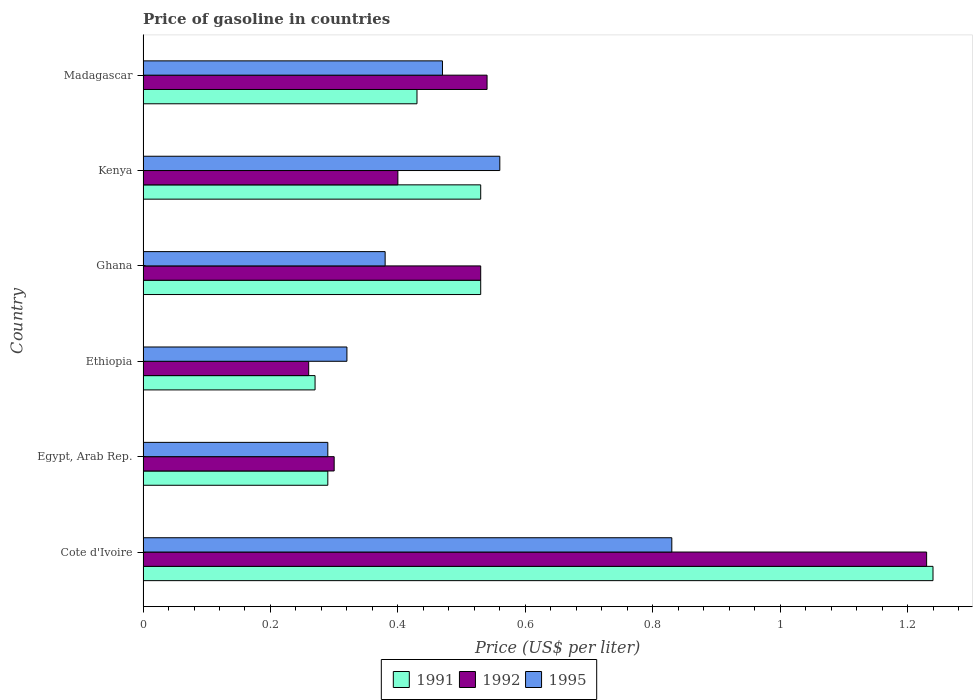Are the number of bars on each tick of the Y-axis equal?
Your response must be concise. Yes. What is the label of the 2nd group of bars from the top?
Your response must be concise. Kenya. In how many cases, is the number of bars for a given country not equal to the number of legend labels?
Ensure brevity in your answer.  0. What is the price of gasoline in 1995 in Madagascar?
Your answer should be very brief. 0.47. Across all countries, what is the maximum price of gasoline in 1991?
Ensure brevity in your answer.  1.24. Across all countries, what is the minimum price of gasoline in 1991?
Your response must be concise. 0.27. In which country was the price of gasoline in 1991 maximum?
Give a very brief answer. Cote d'Ivoire. In which country was the price of gasoline in 1995 minimum?
Ensure brevity in your answer.  Egypt, Arab Rep. What is the total price of gasoline in 1992 in the graph?
Your answer should be compact. 3.26. What is the difference between the price of gasoline in 1995 in Ghana and that in Madagascar?
Make the answer very short. -0.09. What is the difference between the price of gasoline in 1992 in Kenya and the price of gasoline in 1995 in Egypt, Arab Rep.?
Your answer should be very brief. 0.11. What is the average price of gasoline in 1991 per country?
Ensure brevity in your answer.  0.55. What is the difference between the price of gasoline in 1991 and price of gasoline in 1992 in Ghana?
Offer a very short reply. 0. What is the ratio of the price of gasoline in 1991 in Ethiopia to that in Kenya?
Your answer should be very brief. 0.51. Is the difference between the price of gasoline in 1991 in Cote d'Ivoire and Madagascar greater than the difference between the price of gasoline in 1992 in Cote d'Ivoire and Madagascar?
Offer a very short reply. Yes. What is the difference between the highest and the second highest price of gasoline in 1992?
Offer a very short reply. 0.69. What is the difference between the highest and the lowest price of gasoline in 1995?
Your response must be concise. 0.54. Is the sum of the price of gasoline in 1992 in Egypt, Arab Rep. and Madagascar greater than the maximum price of gasoline in 1991 across all countries?
Ensure brevity in your answer.  No. What does the 3rd bar from the top in Madagascar represents?
Make the answer very short. 1991. Is it the case that in every country, the sum of the price of gasoline in 1991 and price of gasoline in 1992 is greater than the price of gasoline in 1995?
Make the answer very short. Yes. How many bars are there?
Your answer should be very brief. 18. How many countries are there in the graph?
Ensure brevity in your answer.  6. Does the graph contain any zero values?
Give a very brief answer. No. Does the graph contain grids?
Keep it short and to the point. No. How are the legend labels stacked?
Offer a very short reply. Horizontal. What is the title of the graph?
Your answer should be very brief. Price of gasoline in countries. Does "1988" appear as one of the legend labels in the graph?
Your answer should be very brief. No. What is the label or title of the X-axis?
Give a very brief answer. Price (US$ per liter). What is the label or title of the Y-axis?
Offer a very short reply. Country. What is the Price (US$ per liter) of 1991 in Cote d'Ivoire?
Your answer should be very brief. 1.24. What is the Price (US$ per liter) of 1992 in Cote d'Ivoire?
Provide a short and direct response. 1.23. What is the Price (US$ per liter) in 1995 in Cote d'Ivoire?
Ensure brevity in your answer.  0.83. What is the Price (US$ per liter) of 1991 in Egypt, Arab Rep.?
Offer a terse response. 0.29. What is the Price (US$ per liter) in 1992 in Egypt, Arab Rep.?
Provide a succinct answer. 0.3. What is the Price (US$ per liter) of 1995 in Egypt, Arab Rep.?
Your answer should be compact. 0.29. What is the Price (US$ per liter) in 1991 in Ethiopia?
Provide a succinct answer. 0.27. What is the Price (US$ per liter) in 1992 in Ethiopia?
Provide a short and direct response. 0.26. What is the Price (US$ per liter) of 1995 in Ethiopia?
Your answer should be compact. 0.32. What is the Price (US$ per liter) in 1991 in Ghana?
Give a very brief answer. 0.53. What is the Price (US$ per liter) of 1992 in Ghana?
Your response must be concise. 0.53. What is the Price (US$ per liter) in 1995 in Ghana?
Provide a short and direct response. 0.38. What is the Price (US$ per liter) in 1991 in Kenya?
Offer a terse response. 0.53. What is the Price (US$ per liter) in 1995 in Kenya?
Your response must be concise. 0.56. What is the Price (US$ per liter) in 1991 in Madagascar?
Your response must be concise. 0.43. What is the Price (US$ per liter) in 1992 in Madagascar?
Ensure brevity in your answer.  0.54. What is the Price (US$ per liter) of 1995 in Madagascar?
Your answer should be compact. 0.47. Across all countries, what is the maximum Price (US$ per liter) of 1991?
Offer a very short reply. 1.24. Across all countries, what is the maximum Price (US$ per liter) of 1992?
Give a very brief answer. 1.23. Across all countries, what is the maximum Price (US$ per liter) of 1995?
Offer a very short reply. 0.83. Across all countries, what is the minimum Price (US$ per liter) in 1991?
Give a very brief answer. 0.27. Across all countries, what is the minimum Price (US$ per liter) of 1992?
Provide a short and direct response. 0.26. Across all countries, what is the minimum Price (US$ per liter) of 1995?
Offer a terse response. 0.29. What is the total Price (US$ per liter) of 1991 in the graph?
Provide a succinct answer. 3.29. What is the total Price (US$ per liter) of 1992 in the graph?
Your answer should be compact. 3.26. What is the total Price (US$ per liter) of 1995 in the graph?
Keep it short and to the point. 2.85. What is the difference between the Price (US$ per liter) of 1992 in Cote d'Ivoire and that in Egypt, Arab Rep.?
Keep it short and to the point. 0.93. What is the difference between the Price (US$ per liter) in 1995 in Cote d'Ivoire and that in Egypt, Arab Rep.?
Make the answer very short. 0.54. What is the difference between the Price (US$ per liter) in 1992 in Cote d'Ivoire and that in Ethiopia?
Provide a succinct answer. 0.97. What is the difference between the Price (US$ per liter) of 1995 in Cote d'Ivoire and that in Ethiopia?
Provide a succinct answer. 0.51. What is the difference between the Price (US$ per liter) in 1991 in Cote d'Ivoire and that in Ghana?
Your answer should be very brief. 0.71. What is the difference between the Price (US$ per liter) of 1992 in Cote d'Ivoire and that in Ghana?
Provide a short and direct response. 0.7. What is the difference between the Price (US$ per liter) of 1995 in Cote d'Ivoire and that in Ghana?
Your answer should be compact. 0.45. What is the difference between the Price (US$ per liter) in 1991 in Cote d'Ivoire and that in Kenya?
Offer a very short reply. 0.71. What is the difference between the Price (US$ per liter) in 1992 in Cote d'Ivoire and that in Kenya?
Ensure brevity in your answer.  0.83. What is the difference between the Price (US$ per liter) in 1995 in Cote d'Ivoire and that in Kenya?
Make the answer very short. 0.27. What is the difference between the Price (US$ per liter) of 1991 in Cote d'Ivoire and that in Madagascar?
Your answer should be compact. 0.81. What is the difference between the Price (US$ per liter) of 1992 in Cote d'Ivoire and that in Madagascar?
Your answer should be very brief. 0.69. What is the difference between the Price (US$ per liter) in 1995 in Cote d'Ivoire and that in Madagascar?
Offer a very short reply. 0.36. What is the difference between the Price (US$ per liter) of 1995 in Egypt, Arab Rep. and that in Ethiopia?
Your response must be concise. -0.03. What is the difference between the Price (US$ per liter) in 1991 in Egypt, Arab Rep. and that in Ghana?
Your answer should be very brief. -0.24. What is the difference between the Price (US$ per liter) in 1992 in Egypt, Arab Rep. and that in Ghana?
Your response must be concise. -0.23. What is the difference between the Price (US$ per liter) in 1995 in Egypt, Arab Rep. and that in Ghana?
Keep it short and to the point. -0.09. What is the difference between the Price (US$ per liter) of 1991 in Egypt, Arab Rep. and that in Kenya?
Provide a short and direct response. -0.24. What is the difference between the Price (US$ per liter) in 1992 in Egypt, Arab Rep. and that in Kenya?
Provide a succinct answer. -0.1. What is the difference between the Price (US$ per liter) in 1995 in Egypt, Arab Rep. and that in Kenya?
Make the answer very short. -0.27. What is the difference between the Price (US$ per liter) of 1991 in Egypt, Arab Rep. and that in Madagascar?
Make the answer very short. -0.14. What is the difference between the Price (US$ per liter) in 1992 in Egypt, Arab Rep. and that in Madagascar?
Provide a short and direct response. -0.24. What is the difference between the Price (US$ per liter) of 1995 in Egypt, Arab Rep. and that in Madagascar?
Offer a terse response. -0.18. What is the difference between the Price (US$ per liter) in 1991 in Ethiopia and that in Ghana?
Offer a very short reply. -0.26. What is the difference between the Price (US$ per liter) of 1992 in Ethiopia and that in Ghana?
Offer a very short reply. -0.27. What is the difference between the Price (US$ per liter) in 1995 in Ethiopia and that in Ghana?
Make the answer very short. -0.06. What is the difference between the Price (US$ per liter) of 1991 in Ethiopia and that in Kenya?
Provide a succinct answer. -0.26. What is the difference between the Price (US$ per liter) in 1992 in Ethiopia and that in Kenya?
Keep it short and to the point. -0.14. What is the difference between the Price (US$ per liter) of 1995 in Ethiopia and that in Kenya?
Offer a very short reply. -0.24. What is the difference between the Price (US$ per liter) in 1991 in Ethiopia and that in Madagascar?
Your answer should be compact. -0.16. What is the difference between the Price (US$ per liter) in 1992 in Ethiopia and that in Madagascar?
Your answer should be very brief. -0.28. What is the difference between the Price (US$ per liter) in 1995 in Ethiopia and that in Madagascar?
Your answer should be compact. -0.15. What is the difference between the Price (US$ per liter) in 1991 in Ghana and that in Kenya?
Give a very brief answer. 0. What is the difference between the Price (US$ per liter) of 1992 in Ghana and that in Kenya?
Offer a terse response. 0.13. What is the difference between the Price (US$ per liter) in 1995 in Ghana and that in Kenya?
Your response must be concise. -0.18. What is the difference between the Price (US$ per liter) in 1992 in Ghana and that in Madagascar?
Keep it short and to the point. -0.01. What is the difference between the Price (US$ per liter) in 1995 in Ghana and that in Madagascar?
Give a very brief answer. -0.09. What is the difference between the Price (US$ per liter) in 1991 in Kenya and that in Madagascar?
Your response must be concise. 0.1. What is the difference between the Price (US$ per liter) in 1992 in Kenya and that in Madagascar?
Give a very brief answer. -0.14. What is the difference between the Price (US$ per liter) of 1995 in Kenya and that in Madagascar?
Provide a short and direct response. 0.09. What is the difference between the Price (US$ per liter) in 1992 in Cote d'Ivoire and the Price (US$ per liter) in 1995 in Egypt, Arab Rep.?
Keep it short and to the point. 0.94. What is the difference between the Price (US$ per liter) of 1991 in Cote d'Ivoire and the Price (US$ per liter) of 1992 in Ethiopia?
Offer a very short reply. 0.98. What is the difference between the Price (US$ per liter) in 1991 in Cote d'Ivoire and the Price (US$ per liter) in 1995 in Ethiopia?
Keep it short and to the point. 0.92. What is the difference between the Price (US$ per liter) in 1992 in Cote d'Ivoire and the Price (US$ per liter) in 1995 in Ethiopia?
Your answer should be very brief. 0.91. What is the difference between the Price (US$ per liter) of 1991 in Cote d'Ivoire and the Price (US$ per liter) of 1992 in Ghana?
Offer a terse response. 0.71. What is the difference between the Price (US$ per liter) in 1991 in Cote d'Ivoire and the Price (US$ per liter) in 1995 in Ghana?
Make the answer very short. 0.86. What is the difference between the Price (US$ per liter) in 1992 in Cote d'Ivoire and the Price (US$ per liter) in 1995 in Ghana?
Your answer should be compact. 0.85. What is the difference between the Price (US$ per liter) in 1991 in Cote d'Ivoire and the Price (US$ per liter) in 1992 in Kenya?
Provide a short and direct response. 0.84. What is the difference between the Price (US$ per liter) in 1991 in Cote d'Ivoire and the Price (US$ per liter) in 1995 in Kenya?
Ensure brevity in your answer.  0.68. What is the difference between the Price (US$ per liter) in 1992 in Cote d'Ivoire and the Price (US$ per liter) in 1995 in Kenya?
Offer a very short reply. 0.67. What is the difference between the Price (US$ per liter) of 1991 in Cote d'Ivoire and the Price (US$ per liter) of 1995 in Madagascar?
Give a very brief answer. 0.77. What is the difference between the Price (US$ per liter) of 1992 in Cote d'Ivoire and the Price (US$ per liter) of 1995 in Madagascar?
Give a very brief answer. 0.76. What is the difference between the Price (US$ per liter) of 1991 in Egypt, Arab Rep. and the Price (US$ per liter) of 1992 in Ethiopia?
Provide a succinct answer. 0.03. What is the difference between the Price (US$ per liter) of 1991 in Egypt, Arab Rep. and the Price (US$ per liter) of 1995 in Ethiopia?
Provide a succinct answer. -0.03. What is the difference between the Price (US$ per liter) in 1992 in Egypt, Arab Rep. and the Price (US$ per liter) in 1995 in Ethiopia?
Provide a succinct answer. -0.02. What is the difference between the Price (US$ per liter) in 1991 in Egypt, Arab Rep. and the Price (US$ per liter) in 1992 in Ghana?
Offer a terse response. -0.24. What is the difference between the Price (US$ per liter) in 1991 in Egypt, Arab Rep. and the Price (US$ per liter) in 1995 in Ghana?
Provide a succinct answer. -0.09. What is the difference between the Price (US$ per liter) of 1992 in Egypt, Arab Rep. and the Price (US$ per liter) of 1995 in Ghana?
Provide a short and direct response. -0.08. What is the difference between the Price (US$ per liter) of 1991 in Egypt, Arab Rep. and the Price (US$ per liter) of 1992 in Kenya?
Make the answer very short. -0.11. What is the difference between the Price (US$ per liter) in 1991 in Egypt, Arab Rep. and the Price (US$ per liter) in 1995 in Kenya?
Provide a succinct answer. -0.27. What is the difference between the Price (US$ per liter) in 1992 in Egypt, Arab Rep. and the Price (US$ per liter) in 1995 in Kenya?
Provide a short and direct response. -0.26. What is the difference between the Price (US$ per liter) in 1991 in Egypt, Arab Rep. and the Price (US$ per liter) in 1995 in Madagascar?
Make the answer very short. -0.18. What is the difference between the Price (US$ per liter) of 1992 in Egypt, Arab Rep. and the Price (US$ per liter) of 1995 in Madagascar?
Provide a short and direct response. -0.17. What is the difference between the Price (US$ per liter) in 1991 in Ethiopia and the Price (US$ per liter) in 1992 in Ghana?
Your response must be concise. -0.26. What is the difference between the Price (US$ per liter) in 1991 in Ethiopia and the Price (US$ per liter) in 1995 in Ghana?
Offer a very short reply. -0.11. What is the difference between the Price (US$ per liter) of 1992 in Ethiopia and the Price (US$ per liter) of 1995 in Ghana?
Make the answer very short. -0.12. What is the difference between the Price (US$ per liter) in 1991 in Ethiopia and the Price (US$ per liter) in 1992 in Kenya?
Your answer should be very brief. -0.13. What is the difference between the Price (US$ per liter) in 1991 in Ethiopia and the Price (US$ per liter) in 1995 in Kenya?
Offer a terse response. -0.29. What is the difference between the Price (US$ per liter) of 1992 in Ethiopia and the Price (US$ per liter) of 1995 in Kenya?
Your answer should be compact. -0.3. What is the difference between the Price (US$ per liter) of 1991 in Ethiopia and the Price (US$ per liter) of 1992 in Madagascar?
Keep it short and to the point. -0.27. What is the difference between the Price (US$ per liter) of 1992 in Ethiopia and the Price (US$ per liter) of 1995 in Madagascar?
Offer a terse response. -0.21. What is the difference between the Price (US$ per liter) of 1991 in Ghana and the Price (US$ per liter) of 1992 in Kenya?
Make the answer very short. 0.13. What is the difference between the Price (US$ per liter) in 1991 in Ghana and the Price (US$ per liter) in 1995 in Kenya?
Provide a succinct answer. -0.03. What is the difference between the Price (US$ per liter) in 1992 in Ghana and the Price (US$ per liter) in 1995 in Kenya?
Ensure brevity in your answer.  -0.03. What is the difference between the Price (US$ per liter) of 1991 in Ghana and the Price (US$ per liter) of 1992 in Madagascar?
Offer a very short reply. -0.01. What is the difference between the Price (US$ per liter) of 1991 in Kenya and the Price (US$ per liter) of 1992 in Madagascar?
Keep it short and to the point. -0.01. What is the difference between the Price (US$ per liter) in 1992 in Kenya and the Price (US$ per liter) in 1995 in Madagascar?
Provide a succinct answer. -0.07. What is the average Price (US$ per liter) of 1991 per country?
Give a very brief answer. 0.55. What is the average Price (US$ per liter) in 1992 per country?
Your answer should be compact. 0.54. What is the average Price (US$ per liter) of 1995 per country?
Make the answer very short. 0.47. What is the difference between the Price (US$ per liter) of 1991 and Price (US$ per liter) of 1992 in Cote d'Ivoire?
Give a very brief answer. 0.01. What is the difference between the Price (US$ per liter) in 1991 and Price (US$ per liter) in 1995 in Cote d'Ivoire?
Provide a short and direct response. 0.41. What is the difference between the Price (US$ per liter) in 1991 and Price (US$ per liter) in 1992 in Egypt, Arab Rep.?
Give a very brief answer. -0.01. What is the difference between the Price (US$ per liter) in 1991 and Price (US$ per liter) in 1995 in Ethiopia?
Your response must be concise. -0.05. What is the difference between the Price (US$ per liter) of 1992 and Price (US$ per liter) of 1995 in Ethiopia?
Provide a succinct answer. -0.06. What is the difference between the Price (US$ per liter) in 1991 and Price (US$ per liter) in 1992 in Ghana?
Your response must be concise. 0. What is the difference between the Price (US$ per liter) of 1991 and Price (US$ per liter) of 1995 in Ghana?
Offer a terse response. 0.15. What is the difference between the Price (US$ per liter) in 1991 and Price (US$ per liter) in 1992 in Kenya?
Your answer should be compact. 0.13. What is the difference between the Price (US$ per liter) in 1991 and Price (US$ per liter) in 1995 in Kenya?
Offer a very short reply. -0.03. What is the difference between the Price (US$ per liter) in 1992 and Price (US$ per liter) in 1995 in Kenya?
Offer a terse response. -0.16. What is the difference between the Price (US$ per liter) of 1991 and Price (US$ per liter) of 1992 in Madagascar?
Your answer should be compact. -0.11. What is the difference between the Price (US$ per liter) in 1991 and Price (US$ per liter) in 1995 in Madagascar?
Provide a succinct answer. -0.04. What is the difference between the Price (US$ per liter) in 1992 and Price (US$ per liter) in 1995 in Madagascar?
Your answer should be compact. 0.07. What is the ratio of the Price (US$ per liter) of 1991 in Cote d'Ivoire to that in Egypt, Arab Rep.?
Your answer should be compact. 4.28. What is the ratio of the Price (US$ per liter) of 1995 in Cote d'Ivoire to that in Egypt, Arab Rep.?
Provide a short and direct response. 2.86. What is the ratio of the Price (US$ per liter) of 1991 in Cote d'Ivoire to that in Ethiopia?
Give a very brief answer. 4.59. What is the ratio of the Price (US$ per liter) of 1992 in Cote d'Ivoire to that in Ethiopia?
Keep it short and to the point. 4.73. What is the ratio of the Price (US$ per liter) in 1995 in Cote d'Ivoire to that in Ethiopia?
Provide a succinct answer. 2.59. What is the ratio of the Price (US$ per liter) of 1991 in Cote d'Ivoire to that in Ghana?
Give a very brief answer. 2.34. What is the ratio of the Price (US$ per liter) in 1992 in Cote d'Ivoire to that in Ghana?
Offer a terse response. 2.32. What is the ratio of the Price (US$ per liter) in 1995 in Cote d'Ivoire to that in Ghana?
Give a very brief answer. 2.18. What is the ratio of the Price (US$ per liter) in 1991 in Cote d'Ivoire to that in Kenya?
Your answer should be very brief. 2.34. What is the ratio of the Price (US$ per liter) of 1992 in Cote d'Ivoire to that in Kenya?
Provide a short and direct response. 3.08. What is the ratio of the Price (US$ per liter) in 1995 in Cote d'Ivoire to that in Kenya?
Make the answer very short. 1.48. What is the ratio of the Price (US$ per liter) of 1991 in Cote d'Ivoire to that in Madagascar?
Offer a very short reply. 2.88. What is the ratio of the Price (US$ per liter) of 1992 in Cote d'Ivoire to that in Madagascar?
Keep it short and to the point. 2.28. What is the ratio of the Price (US$ per liter) of 1995 in Cote d'Ivoire to that in Madagascar?
Your response must be concise. 1.77. What is the ratio of the Price (US$ per liter) of 1991 in Egypt, Arab Rep. to that in Ethiopia?
Keep it short and to the point. 1.07. What is the ratio of the Price (US$ per liter) of 1992 in Egypt, Arab Rep. to that in Ethiopia?
Keep it short and to the point. 1.15. What is the ratio of the Price (US$ per liter) of 1995 in Egypt, Arab Rep. to that in Ethiopia?
Offer a very short reply. 0.91. What is the ratio of the Price (US$ per liter) in 1991 in Egypt, Arab Rep. to that in Ghana?
Offer a very short reply. 0.55. What is the ratio of the Price (US$ per liter) in 1992 in Egypt, Arab Rep. to that in Ghana?
Offer a terse response. 0.57. What is the ratio of the Price (US$ per liter) of 1995 in Egypt, Arab Rep. to that in Ghana?
Offer a very short reply. 0.76. What is the ratio of the Price (US$ per liter) in 1991 in Egypt, Arab Rep. to that in Kenya?
Keep it short and to the point. 0.55. What is the ratio of the Price (US$ per liter) of 1992 in Egypt, Arab Rep. to that in Kenya?
Offer a terse response. 0.75. What is the ratio of the Price (US$ per liter) of 1995 in Egypt, Arab Rep. to that in Kenya?
Give a very brief answer. 0.52. What is the ratio of the Price (US$ per liter) in 1991 in Egypt, Arab Rep. to that in Madagascar?
Give a very brief answer. 0.67. What is the ratio of the Price (US$ per liter) of 1992 in Egypt, Arab Rep. to that in Madagascar?
Keep it short and to the point. 0.56. What is the ratio of the Price (US$ per liter) of 1995 in Egypt, Arab Rep. to that in Madagascar?
Your answer should be very brief. 0.62. What is the ratio of the Price (US$ per liter) of 1991 in Ethiopia to that in Ghana?
Offer a terse response. 0.51. What is the ratio of the Price (US$ per liter) of 1992 in Ethiopia to that in Ghana?
Your answer should be compact. 0.49. What is the ratio of the Price (US$ per liter) in 1995 in Ethiopia to that in Ghana?
Your answer should be compact. 0.84. What is the ratio of the Price (US$ per liter) in 1991 in Ethiopia to that in Kenya?
Your answer should be compact. 0.51. What is the ratio of the Price (US$ per liter) of 1992 in Ethiopia to that in Kenya?
Offer a very short reply. 0.65. What is the ratio of the Price (US$ per liter) of 1991 in Ethiopia to that in Madagascar?
Make the answer very short. 0.63. What is the ratio of the Price (US$ per liter) in 1992 in Ethiopia to that in Madagascar?
Provide a short and direct response. 0.48. What is the ratio of the Price (US$ per liter) in 1995 in Ethiopia to that in Madagascar?
Give a very brief answer. 0.68. What is the ratio of the Price (US$ per liter) of 1991 in Ghana to that in Kenya?
Your answer should be very brief. 1. What is the ratio of the Price (US$ per liter) of 1992 in Ghana to that in Kenya?
Your response must be concise. 1.32. What is the ratio of the Price (US$ per liter) in 1995 in Ghana to that in Kenya?
Provide a short and direct response. 0.68. What is the ratio of the Price (US$ per liter) of 1991 in Ghana to that in Madagascar?
Keep it short and to the point. 1.23. What is the ratio of the Price (US$ per liter) in 1992 in Ghana to that in Madagascar?
Provide a succinct answer. 0.98. What is the ratio of the Price (US$ per liter) of 1995 in Ghana to that in Madagascar?
Provide a short and direct response. 0.81. What is the ratio of the Price (US$ per liter) of 1991 in Kenya to that in Madagascar?
Your answer should be very brief. 1.23. What is the ratio of the Price (US$ per liter) in 1992 in Kenya to that in Madagascar?
Your answer should be very brief. 0.74. What is the ratio of the Price (US$ per liter) in 1995 in Kenya to that in Madagascar?
Make the answer very short. 1.19. What is the difference between the highest and the second highest Price (US$ per liter) of 1991?
Keep it short and to the point. 0.71. What is the difference between the highest and the second highest Price (US$ per liter) in 1992?
Give a very brief answer. 0.69. What is the difference between the highest and the second highest Price (US$ per liter) in 1995?
Your response must be concise. 0.27. What is the difference between the highest and the lowest Price (US$ per liter) in 1991?
Offer a terse response. 0.97. What is the difference between the highest and the lowest Price (US$ per liter) of 1995?
Ensure brevity in your answer.  0.54. 